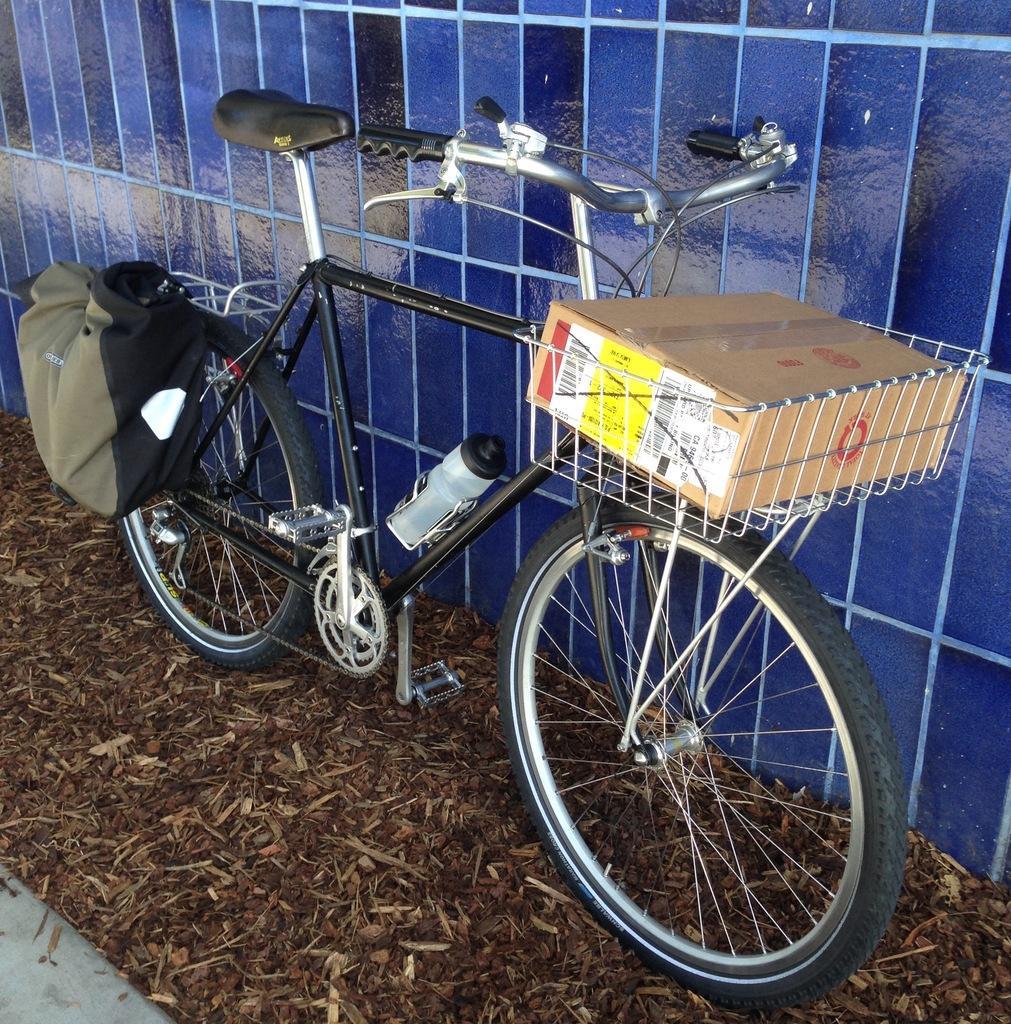Can you describe this image briefly? In this image we can see a bicycle on the floor with cardboard carton, disposal bottle and a bag. In the foreground we can see saw dust and twigs. 